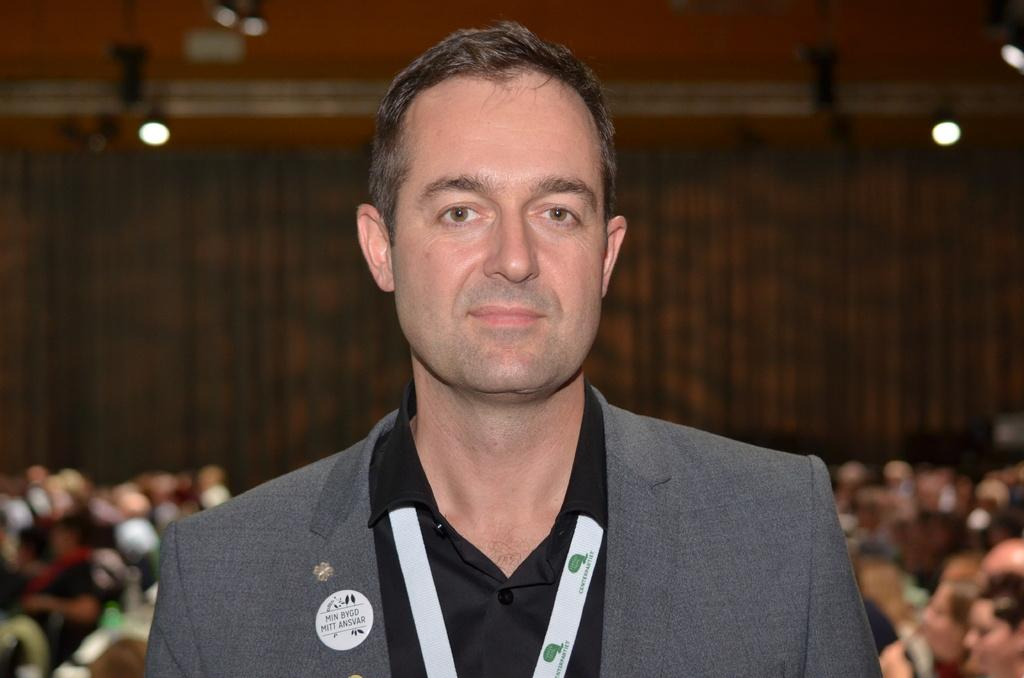What is the main subject of the image? There is a person in the image. Can you describe the group of people in the image? There is a group of people sitting on the backside in the image. What is the background of the image? There is a wall in the image. What can be seen illuminating the scene? There are lights visible in the image. What type of shade is being provided by the crow in the image? There is no crow present in the image, so no shade is being provided by a crow. 